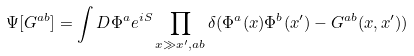Convert formula to latex. <formula><loc_0><loc_0><loc_500><loc_500>\Psi [ G ^ { a b } ] = \int D \Phi ^ { a } e ^ { i S } \prod _ { x \gg x ^ { \prime } , a b } \delta ( \Phi ^ { a } ( x ) \Phi ^ { b } ( x ^ { \prime } ) - G ^ { a b } ( x , x ^ { \prime } ) )</formula> 